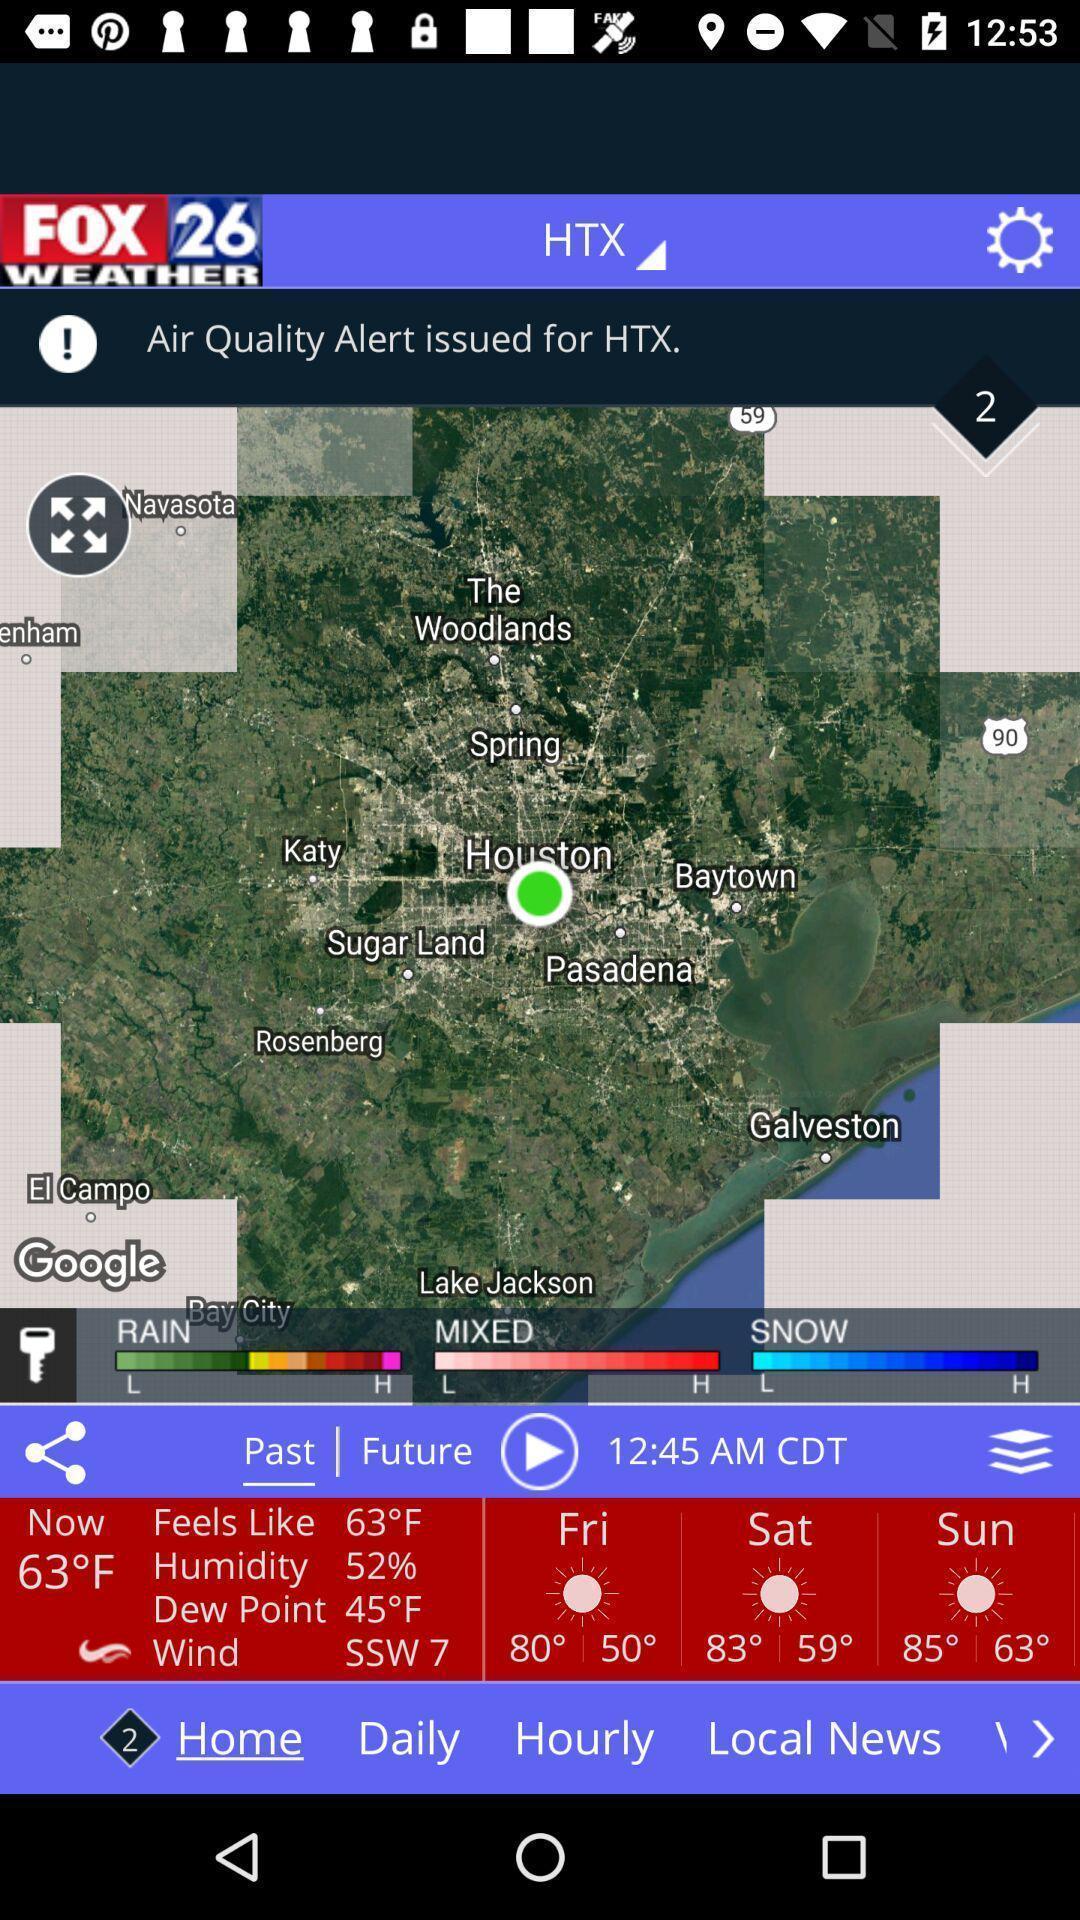Tell me about the visual elements in this screen capture. Page showing weather report with map in weather forecasting app. 